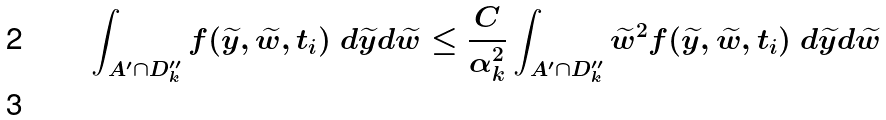<formula> <loc_0><loc_0><loc_500><loc_500>\int _ { A ^ { \prime } \cap D _ { k } ^ { \prime \prime } } f ( \widetilde { y } , \widetilde { w } , t _ { i } ) \ d \widetilde { y } d \widetilde { w } & \leq \frac { C } { \alpha _ { k } ^ { 2 } } \int _ { A ^ { \prime } \cap D _ { k } ^ { \prime \prime } } \widetilde { w } ^ { 2 } f ( \widetilde { y } , \widetilde { w } , t _ { i } ) \ d \widetilde { y } d \widetilde { w } \\ &</formula> 